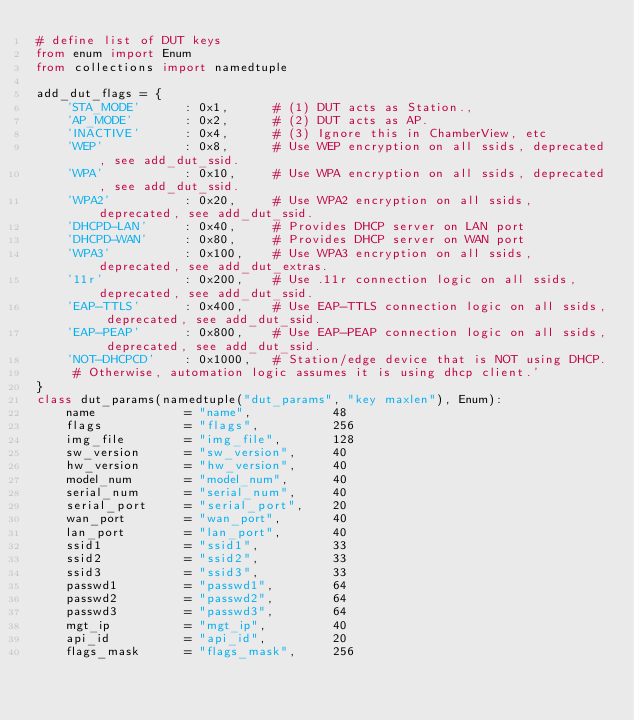Convert code to text. <code><loc_0><loc_0><loc_500><loc_500><_Python_># define list of DUT keys
from enum import Enum
from collections import namedtuple

add_dut_flags = {
    'STA_MODE'      : 0x1,      # (1) DUT acts as Station.,
    'AP_MODE'       : 0x2,      # (2) DUT acts as AP.
    'INACTIVE'      : 0x4,      # (3) Ignore this in ChamberView, etc
    'WEP'           : 0x8,      # Use WEP encryption on all ssids, deprecated, see add_dut_ssid.
    'WPA'           : 0x10,     # Use WPA encryption on all ssids, deprecated, see add_dut_ssid.
    'WPA2'          : 0x20,     # Use WPA2 encryption on all ssids, deprecated, see add_dut_ssid.
    'DHCPD-LAN'     : 0x40,     # Provides DHCP server on LAN port
    'DHCPD-WAN'     : 0x80,     # Provides DHCP server on WAN port
    'WPA3'          : 0x100,    # Use WPA3 encryption on all ssids, deprecated, see add_dut_extras.
    '11r'           : 0x200,    # Use .11r connection logic on all ssids, deprecated, see add_dut_ssid.
    'EAP-TTLS'      : 0x400,    # Use EAP-TTLS connection logic on all ssids, deprecated, see add_dut_ssid.
    'EAP-PEAP'      : 0x800,    # Use EAP-PEAP connection logic on all ssids, deprecated, see add_dut_ssid.
    'NOT-DHCPCD'    : 0x1000,   # Station/edge device that is NOT using DHCP.
     # Otherwise, automation logic assumes it is using dhcp client.'
}
class dut_params(namedtuple("dut_params", "key maxlen"), Enum):
    name            = "name",           48
    flags           = "flags",          256
    img_file        = "img_file",       128
    sw_version      = "sw_version",     40
    hw_version      = "hw_version",     40
    model_num       = "model_num",      40
    serial_num      = "serial_num",     40
    serial_port     = "serial_port",    20
    wan_port        = "wan_port",       40
    lan_port        = "lan_port",       40
    ssid1           = "ssid1",          33
    ssid2           = "ssid2",          33
    ssid3           = "ssid3",          33
    passwd1         = "passwd1",        64
    passwd2         = "passwd2",        64
    passwd3         = "passwd3",        64
    mgt_ip          = "mgt_ip",         40
    api_id          = "api_id",         20
    flags_mask      = "flags_mask",     256</code> 